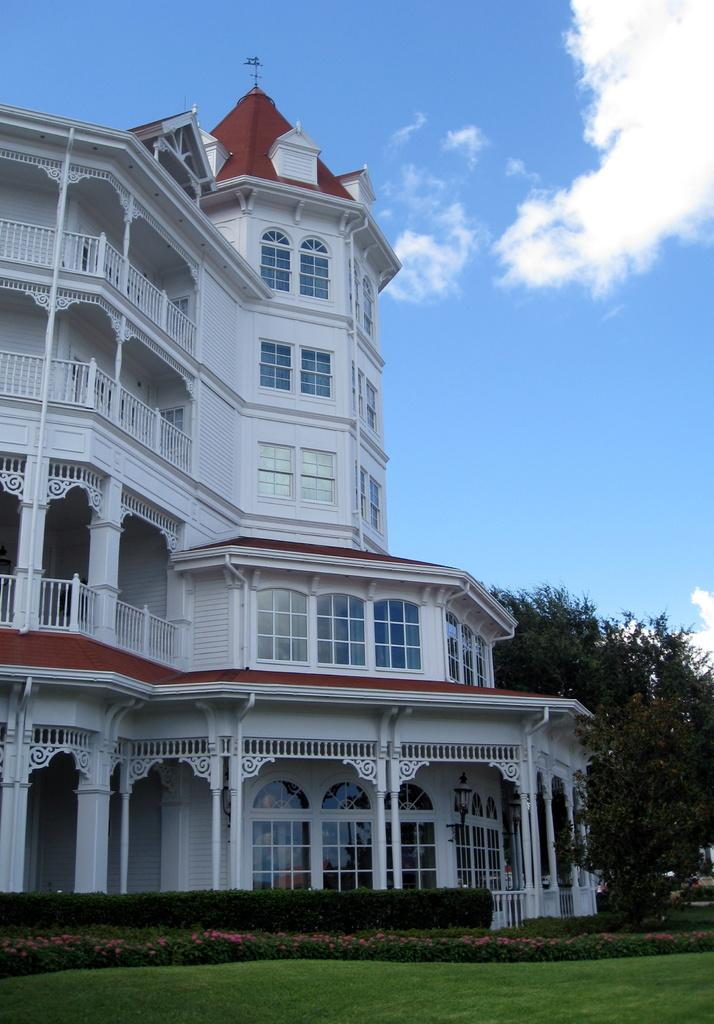What type of structure is visible in the image? There is a building in the image. What type of vegetation can be seen in the image? There are trees and plants in the image. What is on the ground in the image? There is grass on the ground in the image. How would you describe the sky in the image? The sky is blue and cloudy in the image. How many deer are visible in the image? There are no deer present in the image. What is the level of friction between the building and the trees in the image? The level of friction between the building and the trees cannot be determined from the image. 